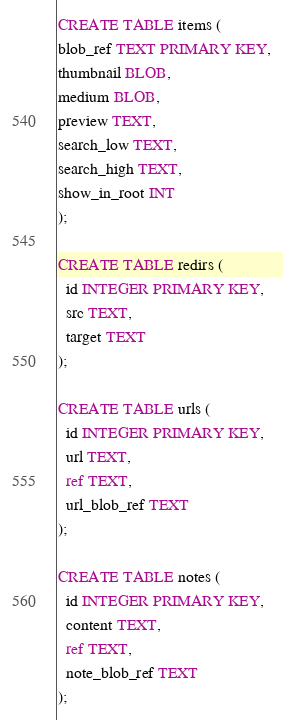Convert code to text. <code><loc_0><loc_0><loc_500><loc_500><_SQL_>CREATE TABLE items (
blob_ref TEXT PRIMARY KEY,
thumbnail BLOB,
medium BLOB,
preview TEXT,
search_low TEXT,
search_high TEXT,
show_in_root INT
);

CREATE TABLE redirs (
  id INTEGER PRIMARY KEY,
  src TEXT,
  target TEXT
);

CREATE TABLE urls (
  id INTEGER PRIMARY KEY,
  url TEXT,
  ref TEXT,
  url_blob_ref TEXT
);

CREATE TABLE notes (
  id INTEGER PRIMARY KEY,
  content TEXT,
  ref TEXT,
  note_blob_ref TEXT
);
</code> 